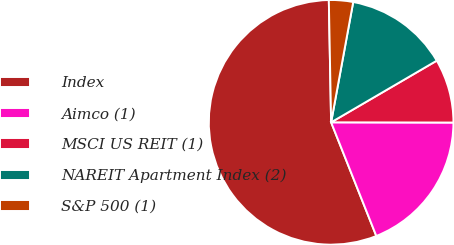<chart> <loc_0><loc_0><loc_500><loc_500><pie_chart><fcel>Index<fcel>Aimco (1)<fcel>MSCI US REIT (1)<fcel>NAREIT Apartment Index (2)<fcel>S&P 500 (1)<nl><fcel>55.73%<fcel>18.95%<fcel>8.44%<fcel>13.7%<fcel>3.19%<nl></chart> 